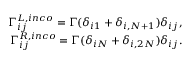<formula> <loc_0><loc_0><loc_500><loc_500>\begin{array} { r } { \Gamma _ { i j } ^ { L , i n c o } = \Gamma ( \delta _ { i 1 } + \delta _ { i , N + 1 } ) \delta _ { i j } , } \\ { \Gamma _ { i j } ^ { R , i n c o } = \Gamma ( \delta _ { i N } + \delta _ { i , 2 N } ) \delta _ { i j } . } \end{array}</formula> 